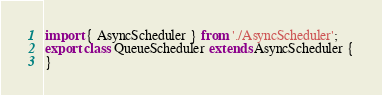Convert code to text. <code><loc_0><loc_0><loc_500><loc_500><_JavaScript_>import { AsyncScheduler } from './AsyncScheduler';
export class QueueScheduler extends AsyncScheduler {
}
</code> 